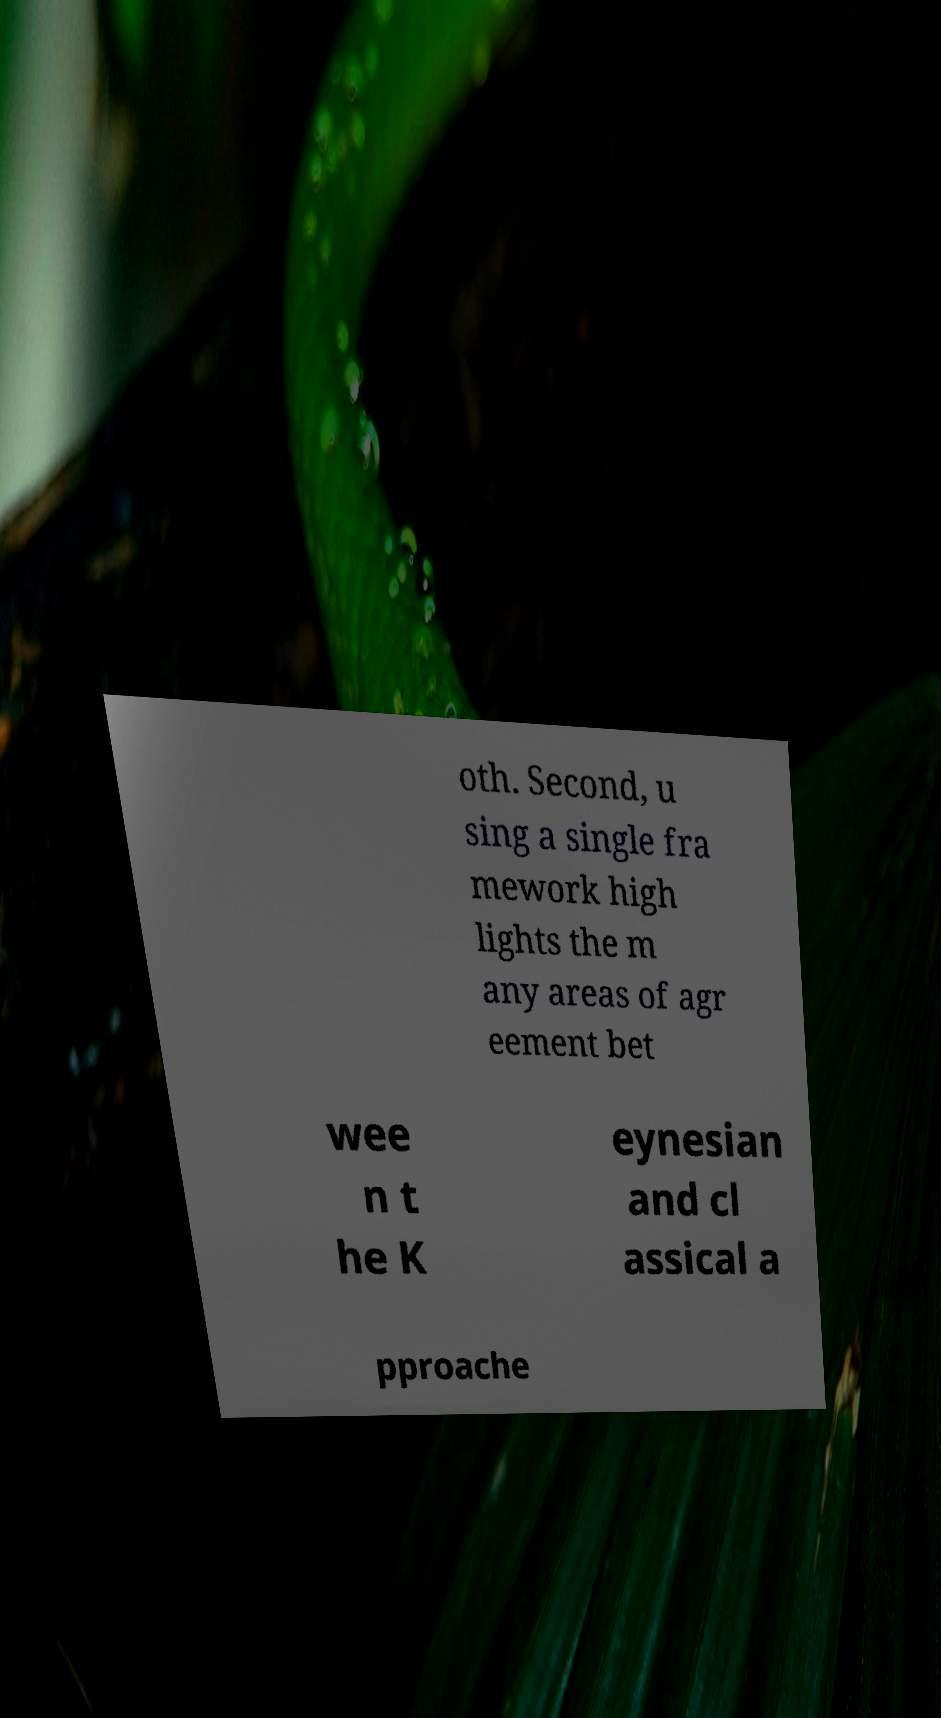Can you read and provide the text displayed in the image?This photo seems to have some interesting text. Can you extract and type it out for me? oth. Second, u sing a single fra mework high lights the m any areas of agr eement bet wee n t he K eynesian and cl assical a pproache 